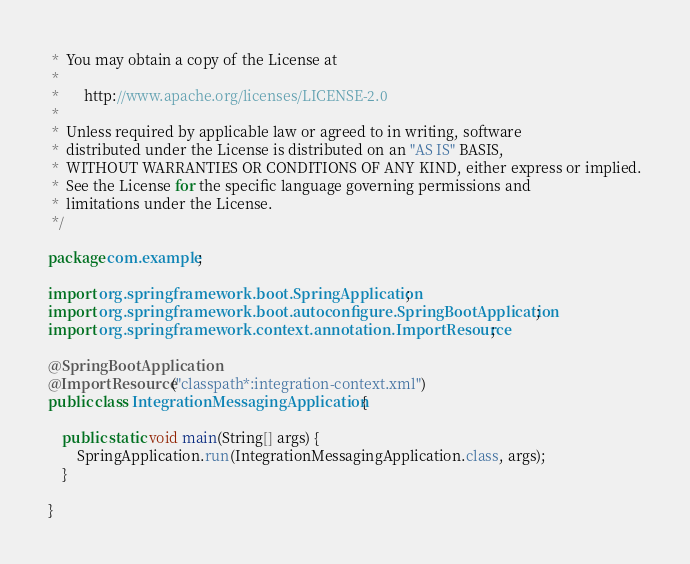<code> <loc_0><loc_0><loc_500><loc_500><_Java_> *  You may obtain a copy of the License at
 *
 *       http://www.apache.org/licenses/LICENSE-2.0
 *
 *  Unless required by applicable law or agreed to in writing, software
 *  distributed under the License is distributed on an "AS IS" BASIS,
 *  WITHOUT WARRANTIES OR CONDITIONS OF ANY KIND, either express or implied.
 *  See the License for the specific language governing permissions and
 *  limitations under the License.
 */

package com.example;

import org.springframework.boot.SpringApplication;
import org.springframework.boot.autoconfigure.SpringBootApplication;
import org.springframework.context.annotation.ImportResource;

@SpringBootApplication
@ImportResource("classpath*:integration-context.xml")
public class IntegrationMessagingApplication {

	public static void main(String[] args) {
		SpringApplication.run(IntegrationMessagingApplication.class, args);
	}

}
</code> 